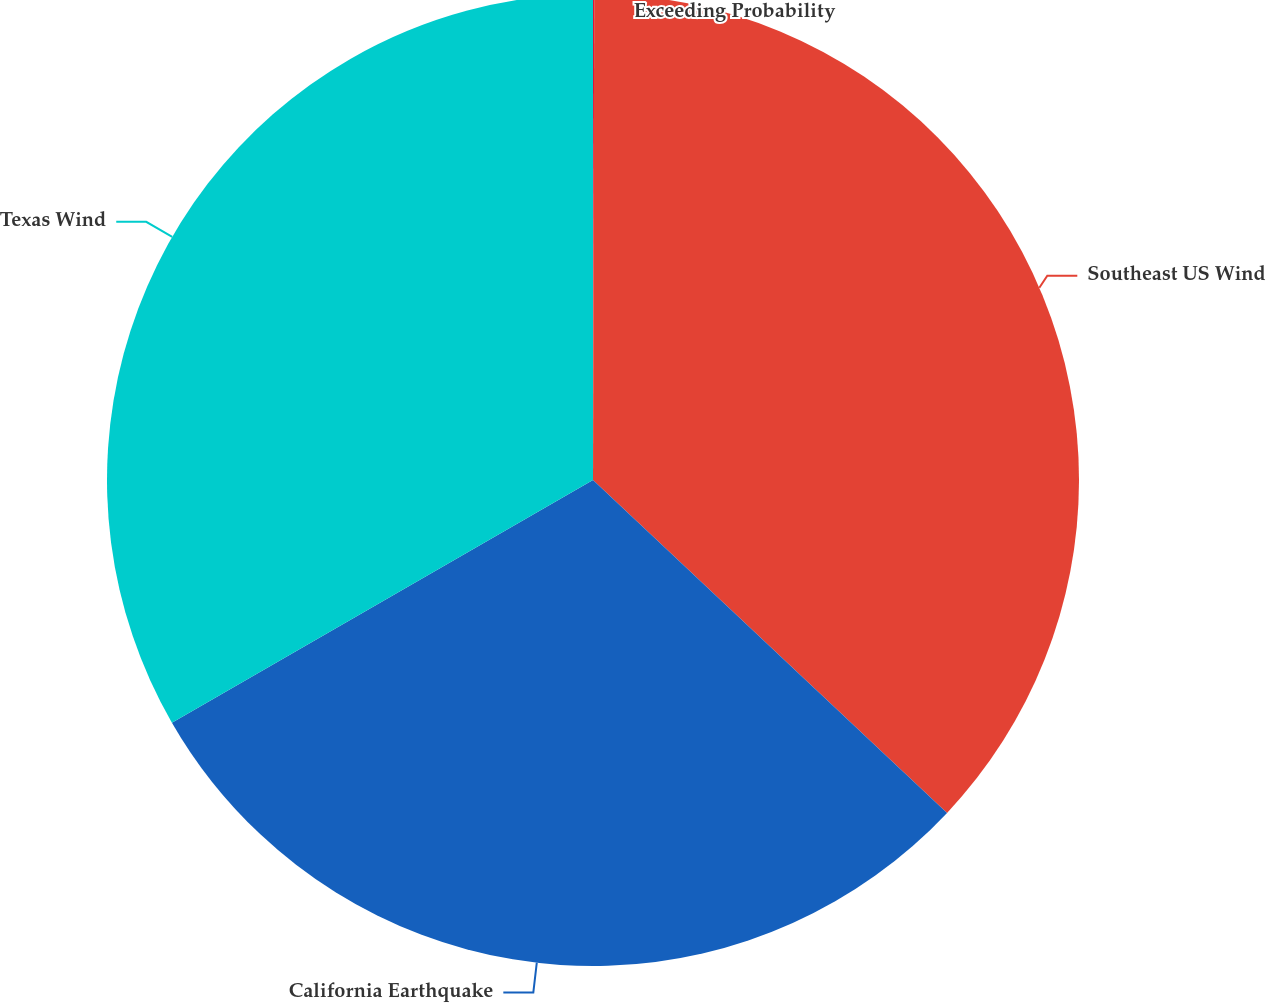Convert chart to OTSL. <chart><loc_0><loc_0><loc_500><loc_500><pie_chart><fcel>Exceeding Probability<fcel>Southeast US Wind<fcel>California Earthquake<fcel>Texas Wind<nl><fcel>0.04%<fcel>36.97%<fcel>29.67%<fcel>33.32%<nl></chart> 